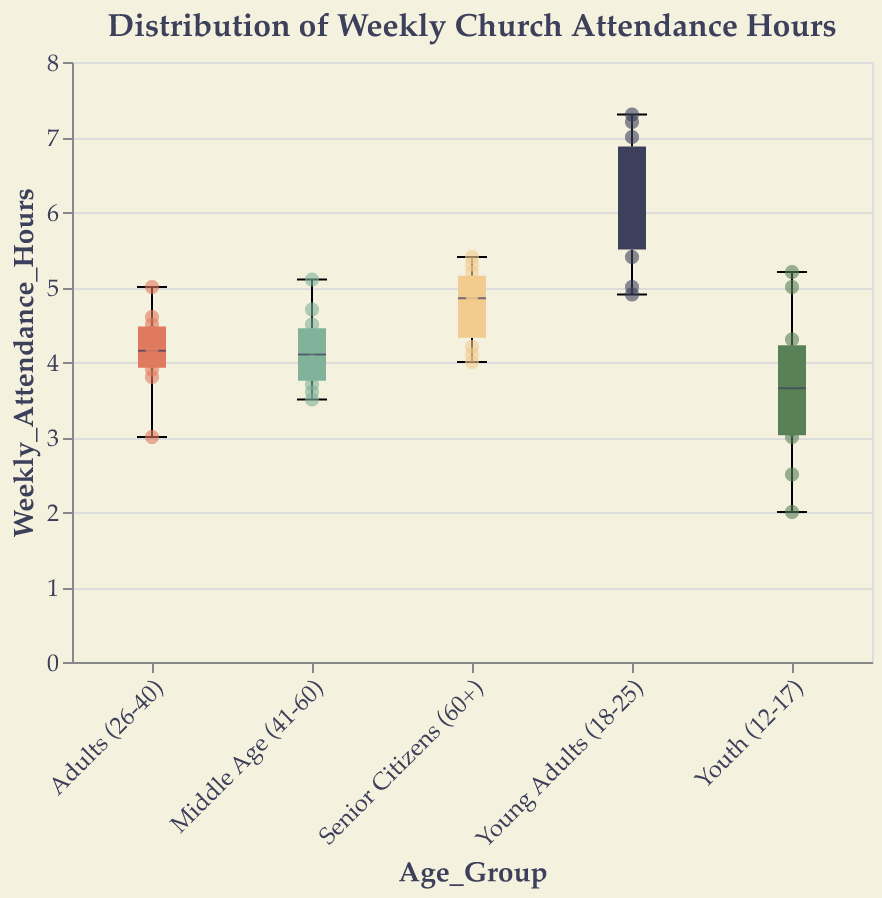What is the title of the figure? The title of the figure is displayed at the top and reads "Distribution of Weekly Church Attendance Hours".
Answer: Distribution of Weekly Church Attendance Hours Which age group has the lowest median weekly church attendance hours? By examining the box plots, the median is marked by a central line in each box. The Youth (12-17) group has the lowest median among the age groups shown.
Answer: Youth (12-17) What is the interquartile range (IQR) for the Young Adults (18-25) group? The interquartile range (IQR) is the range between the first quartile (Q1) and third quartile (Q3). Visually, for the Young Adults (18-25), Q1 is approximately 5.2 and Q3 is around 7. The IQR is thus 7 - 5.2.
Answer: 1.8 Which age group has the highest maximum weekly church attendance hours? In the box plots, the maximum values are indicated by the top whiskers. The Young Adults (18-25) group has the highest maximum value.
Answer: Young Adults (18-25) Compare the median weekly church attendance hours of the Adults (26-40) and Senior Citizens (60+) groups. Which one is higher? By inspecting the central line in the box plots for each age group, the Senior Citizens (60+) group has a higher median weekly church attendance hours compared to the Adults (26-40) group.
Answer: Senior Citizens (60+) What is the approximate median weekly church attendance hours for the Middle Age (41-60) group? The median is marked by the central line inside the box plot for Middle Age (41-60). The median is around 4 hours.
Answer: 4 hours How does the spread of weekly church attendance hours for Youth (12-17) compare to Senior Citizens (60+)? The Youth (12-17) box plot shows a wider spread between the minimum and maximum values, indicating more variability in their weekly church attendance hours compared to Senior Citizens (60+), which have a narrower spread.
Answer: Youth (12-17) has a wider spread What are the minimum and maximum weekly church attendance hours for the Adults (26-40) group? The minimum is represented by the lower whisker, and the maximum by the upper whisker in the box plot for Adults (26-40). The minimum is around 3 hours, and the maximum is around 5 hours.
Answer: Min: 3 hours, Max: 5 hours Which group has a higher interquartile range (IQR): Middle Age (41-60) or Senior Citizens (60+)? The IQR is the range between the first and third quartiles. For Middle Age (41-60), it's approximately 3.6 to 4.7 (1.1). For Senior Citizens (60+), it's approximately 4.2 to 5 (0.8). The Middle Age (41-60) group has a higher IQR.
Answer: Middle Age (41-60) Are there any outliers in the Young Adults (18-25) group? In a box plot, outliers are points outside the whiskers’ range. The scatter points for Young Adults (18-25) show no points outside the whiskers, indicating no outliers.
Answer: No 